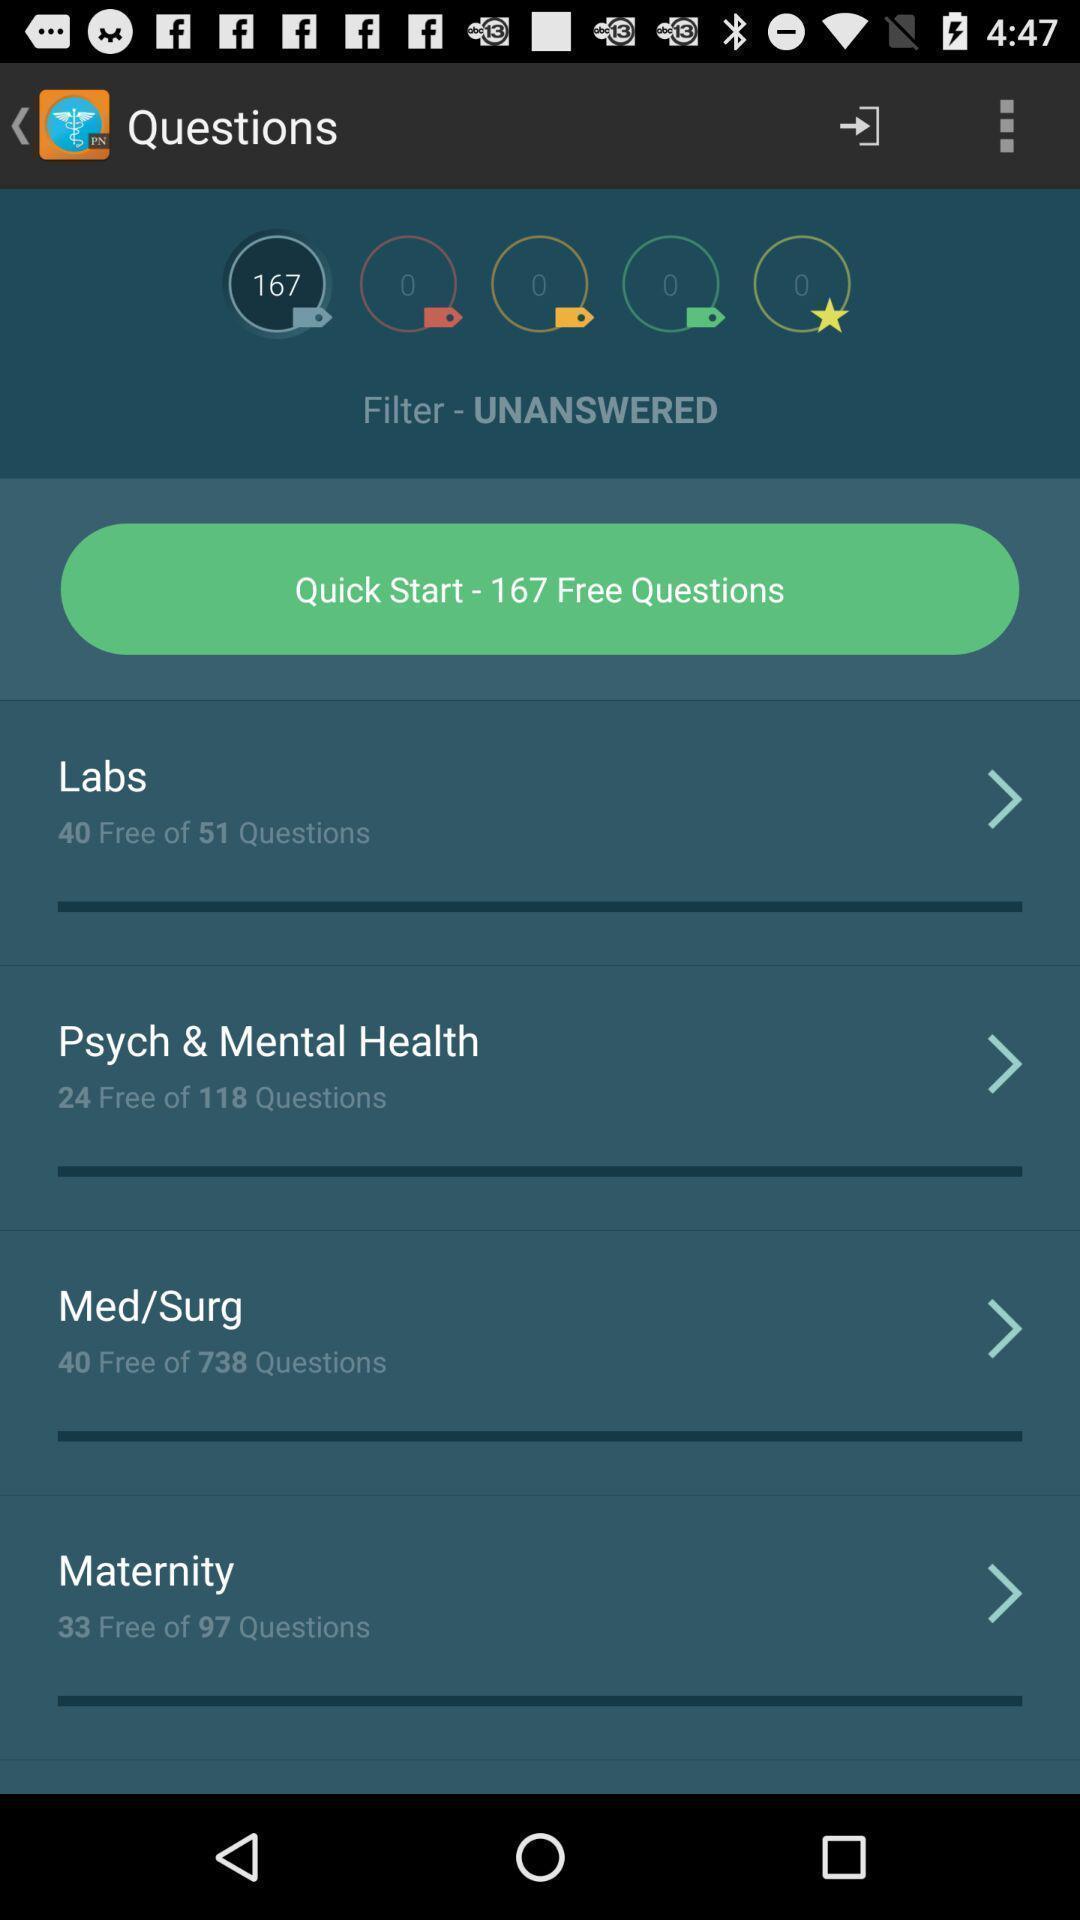Tell me about the visual elements in this screen capture. Page displaying with list of different aspects in healthcare application. 